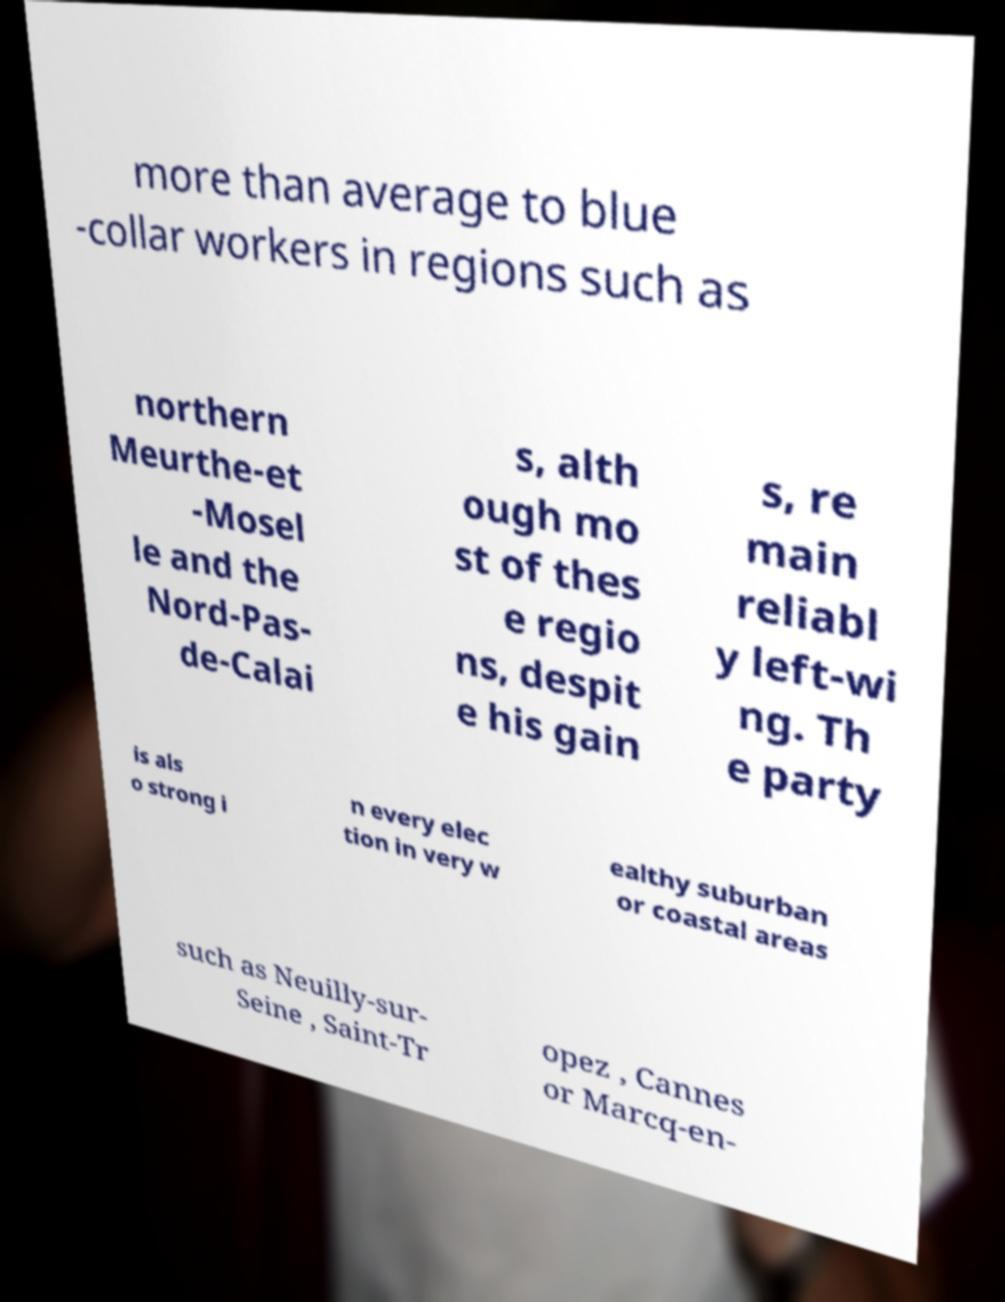There's text embedded in this image that I need extracted. Can you transcribe it verbatim? more than average to blue -collar workers in regions such as northern Meurthe-et -Mosel le and the Nord-Pas- de-Calai s, alth ough mo st of thes e regio ns, despit e his gain s, re main reliabl y left-wi ng. Th e party is als o strong i n every elec tion in very w ealthy suburban or coastal areas such as Neuilly-sur- Seine , Saint-Tr opez , Cannes or Marcq-en- 